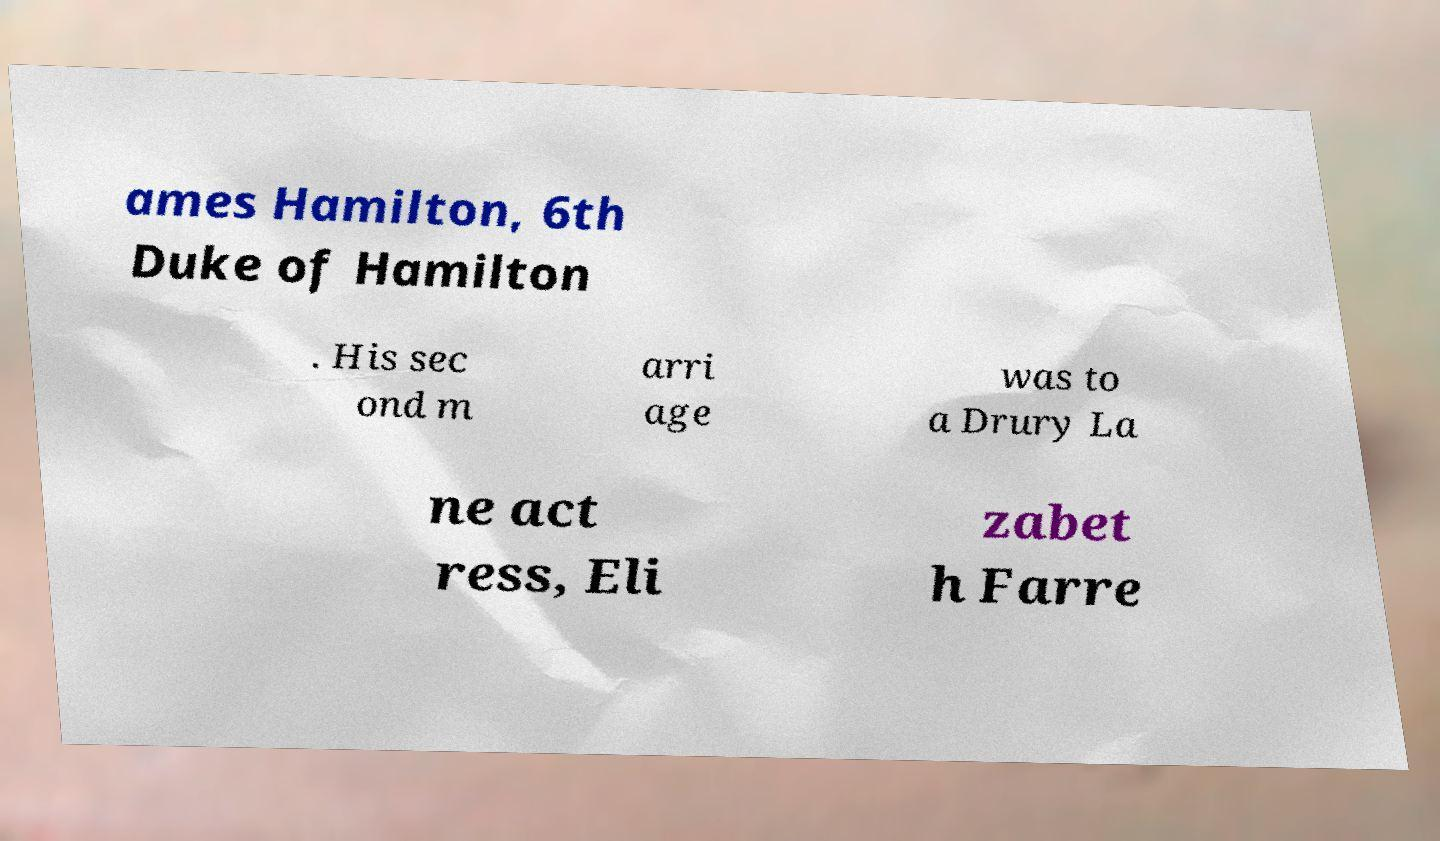What messages or text are displayed in this image? I need them in a readable, typed format. ames Hamilton, 6th Duke of Hamilton . His sec ond m arri age was to a Drury La ne act ress, Eli zabet h Farre 